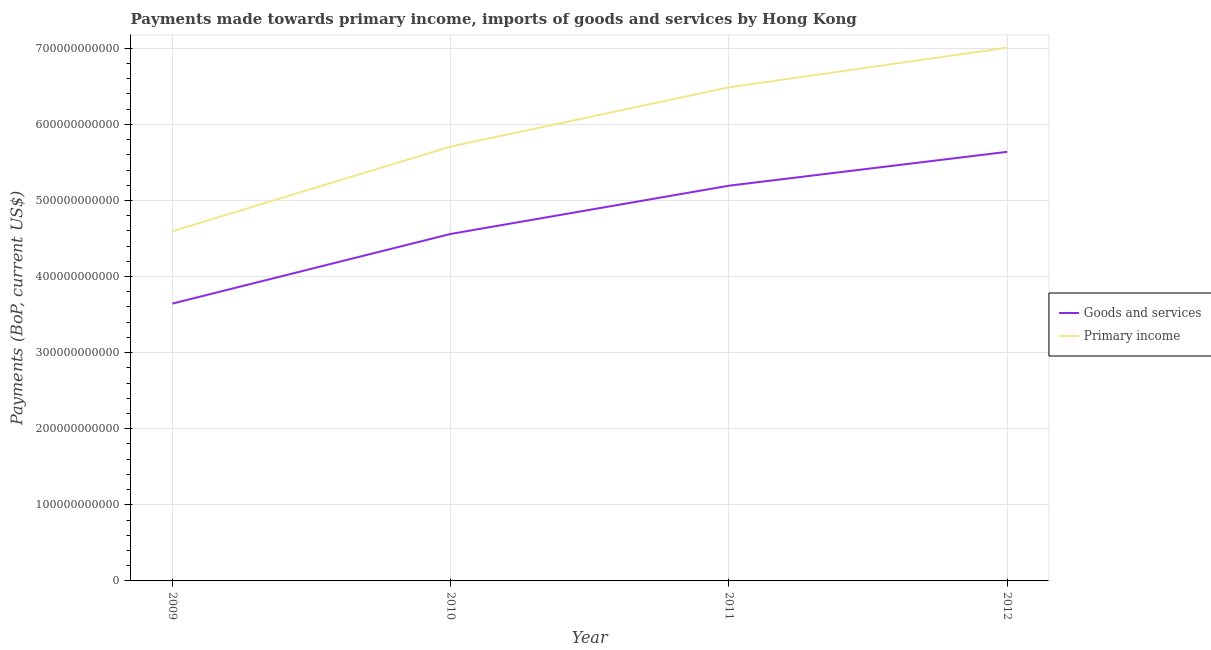Does the line corresponding to payments made towards goods and services intersect with the line corresponding to payments made towards primary income?
Offer a terse response. No. Is the number of lines equal to the number of legend labels?
Keep it short and to the point. Yes. What is the payments made towards goods and services in 2009?
Keep it short and to the point. 3.64e+11. Across all years, what is the maximum payments made towards goods and services?
Offer a terse response. 5.64e+11. Across all years, what is the minimum payments made towards primary income?
Provide a succinct answer. 4.60e+11. In which year was the payments made towards goods and services minimum?
Offer a very short reply. 2009. What is the total payments made towards primary income in the graph?
Ensure brevity in your answer.  2.38e+12. What is the difference between the payments made towards primary income in 2010 and that in 2011?
Your answer should be very brief. -7.79e+1. What is the difference between the payments made towards primary income in 2011 and the payments made towards goods and services in 2009?
Ensure brevity in your answer.  2.84e+11. What is the average payments made towards goods and services per year?
Make the answer very short. 4.76e+11. In the year 2010, what is the difference between the payments made towards goods and services and payments made towards primary income?
Provide a succinct answer. -1.15e+11. What is the ratio of the payments made towards goods and services in 2010 to that in 2011?
Your answer should be very brief. 0.88. Is the payments made towards primary income in 2009 less than that in 2011?
Offer a terse response. Yes. What is the difference between the highest and the second highest payments made towards primary income?
Your answer should be very brief. 5.21e+1. What is the difference between the highest and the lowest payments made towards primary income?
Ensure brevity in your answer.  2.41e+11. In how many years, is the payments made towards goods and services greater than the average payments made towards goods and services taken over all years?
Ensure brevity in your answer.  2. Is the sum of the payments made towards primary income in 2010 and 2011 greater than the maximum payments made towards goods and services across all years?
Give a very brief answer. Yes. Does the payments made towards goods and services monotonically increase over the years?
Provide a short and direct response. Yes. Is the payments made towards goods and services strictly less than the payments made towards primary income over the years?
Keep it short and to the point. Yes. What is the difference between two consecutive major ticks on the Y-axis?
Keep it short and to the point. 1.00e+11. What is the title of the graph?
Keep it short and to the point. Payments made towards primary income, imports of goods and services by Hong Kong. What is the label or title of the X-axis?
Provide a succinct answer. Year. What is the label or title of the Y-axis?
Ensure brevity in your answer.  Payments (BoP, current US$). What is the Payments (BoP, current US$) of Goods and services in 2009?
Your answer should be compact. 3.64e+11. What is the Payments (BoP, current US$) in Primary income in 2009?
Give a very brief answer. 4.60e+11. What is the Payments (BoP, current US$) of Goods and services in 2010?
Ensure brevity in your answer.  4.56e+11. What is the Payments (BoP, current US$) of Primary income in 2010?
Offer a terse response. 5.71e+11. What is the Payments (BoP, current US$) of Goods and services in 2011?
Make the answer very short. 5.19e+11. What is the Payments (BoP, current US$) of Primary income in 2011?
Offer a terse response. 6.49e+11. What is the Payments (BoP, current US$) of Goods and services in 2012?
Make the answer very short. 5.64e+11. What is the Payments (BoP, current US$) in Primary income in 2012?
Ensure brevity in your answer.  7.01e+11. Across all years, what is the maximum Payments (BoP, current US$) of Goods and services?
Your answer should be very brief. 5.64e+11. Across all years, what is the maximum Payments (BoP, current US$) of Primary income?
Make the answer very short. 7.01e+11. Across all years, what is the minimum Payments (BoP, current US$) of Goods and services?
Keep it short and to the point. 3.64e+11. Across all years, what is the minimum Payments (BoP, current US$) in Primary income?
Your response must be concise. 4.60e+11. What is the total Payments (BoP, current US$) in Goods and services in the graph?
Give a very brief answer. 1.90e+12. What is the total Payments (BoP, current US$) in Primary income in the graph?
Your answer should be compact. 2.38e+12. What is the difference between the Payments (BoP, current US$) in Goods and services in 2009 and that in 2010?
Ensure brevity in your answer.  -9.16e+1. What is the difference between the Payments (BoP, current US$) of Primary income in 2009 and that in 2010?
Ensure brevity in your answer.  -1.11e+11. What is the difference between the Payments (BoP, current US$) of Goods and services in 2009 and that in 2011?
Ensure brevity in your answer.  -1.55e+11. What is the difference between the Payments (BoP, current US$) in Primary income in 2009 and that in 2011?
Make the answer very short. -1.89e+11. What is the difference between the Payments (BoP, current US$) of Goods and services in 2009 and that in 2012?
Your answer should be compact. -1.99e+11. What is the difference between the Payments (BoP, current US$) of Primary income in 2009 and that in 2012?
Provide a succinct answer. -2.41e+11. What is the difference between the Payments (BoP, current US$) of Goods and services in 2010 and that in 2011?
Offer a very short reply. -6.34e+1. What is the difference between the Payments (BoP, current US$) in Primary income in 2010 and that in 2011?
Ensure brevity in your answer.  -7.79e+1. What is the difference between the Payments (BoP, current US$) in Goods and services in 2010 and that in 2012?
Your response must be concise. -1.08e+11. What is the difference between the Payments (BoP, current US$) in Primary income in 2010 and that in 2012?
Your response must be concise. -1.30e+11. What is the difference between the Payments (BoP, current US$) of Goods and services in 2011 and that in 2012?
Your answer should be compact. -4.45e+1. What is the difference between the Payments (BoP, current US$) in Primary income in 2011 and that in 2012?
Your answer should be compact. -5.21e+1. What is the difference between the Payments (BoP, current US$) in Goods and services in 2009 and the Payments (BoP, current US$) in Primary income in 2010?
Keep it short and to the point. -2.06e+11. What is the difference between the Payments (BoP, current US$) in Goods and services in 2009 and the Payments (BoP, current US$) in Primary income in 2011?
Provide a short and direct response. -2.84e+11. What is the difference between the Payments (BoP, current US$) in Goods and services in 2009 and the Payments (BoP, current US$) in Primary income in 2012?
Your answer should be compact. -3.36e+11. What is the difference between the Payments (BoP, current US$) of Goods and services in 2010 and the Payments (BoP, current US$) of Primary income in 2011?
Your answer should be compact. -1.93e+11. What is the difference between the Payments (BoP, current US$) in Goods and services in 2010 and the Payments (BoP, current US$) in Primary income in 2012?
Your answer should be very brief. -2.45e+11. What is the difference between the Payments (BoP, current US$) of Goods and services in 2011 and the Payments (BoP, current US$) of Primary income in 2012?
Make the answer very short. -1.81e+11. What is the average Payments (BoP, current US$) in Goods and services per year?
Keep it short and to the point. 4.76e+11. What is the average Payments (BoP, current US$) of Primary income per year?
Offer a very short reply. 5.95e+11. In the year 2009, what is the difference between the Payments (BoP, current US$) in Goods and services and Payments (BoP, current US$) in Primary income?
Offer a terse response. -9.51e+1. In the year 2010, what is the difference between the Payments (BoP, current US$) in Goods and services and Payments (BoP, current US$) in Primary income?
Your answer should be very brief. -1.15e+11. In the year 2011, what is the difference between the Payments (BoP, current US$) of Goods and services and Payments (BoP, current US$) of Primary income?
Make the answer very short. -1.29e+11. In the year 2012, what is the difference between the Payments (BoP, current US$) of Goods and services and Payments (BoP, current US$) of Primary income?
Make the answer very short. -1.37e+11. What is the ratio of the Payments (BoP, current US$) in Goods and services in 2009 to that in 2010?
Provide a succinct answer. 0.8. What is the ratio of the Payments (BoP, current US$) in Primary income in 2009 to that in 2010?
Your answer should be compact. 0.81. What is the ratio of the Payments (BoP, current US$) of Goods and services in 2009 to that in 2011?
Offer a terse response. 0.7. What is the ratio of the Payments (BoP, current US$) in Primary income in 2009 to that in 2011?
Provide a short and direct response. 0.71. What is the ratio of the Payments (BoP, current US$) of Goods and services in 2009 to that in 2012?
Your answer should be very brief. 0.65. What is the ratio of the Payments (BoP, current US$) of Primary income in 2009 to that in 2012?
Ensure brevity in your answer.  0.66. What is the ratio of the Payments (BoP, current US$) in Goods and services in 2010 to that in 2011?
Keep it short and to the point. 0.88. What is the ratio of the Payments (BoP, current US$) in Primary income in 2010 to that in 2011?
Make the answer very short. 0.88. What is the ratio of the Payments (BoP, current US$) of Goods and services in 2010 to that in 2012?
Offer a terse response. 0.81. What is the ratio of the Payments (BoP, current US$) in Primary income in 2010 to that in 2012?
Provide a succinct answer. 0.81. What is the ratio of the Payments (BoP, current US$) in Goods and services in 2011 to that in 2012?
Your answer should be very brief. 0.92. What is the ratio of the Payments (BoP, current US$) in Primary income in 2011 to that in 2012?
Your answer should be very brief. 0.93. What is the difference between the highest and the second highest Payments (BoP, current US$) in Goods and services?
Give a very brief answer. 4.45e+1. What is the difference between the highest and the second highest Payments (BoP, current US$) in Primary income?
Make the answer very short. 5.21e+1. What is the difference between the highest and the lowest Payments (BoP, current US$) in Goods and services?
Ensure brevity in your answer.  1.99e+11. What is the difference between the highest and the lowest Payments (BoP, current US$) of Primary income?
Give a very brief answer. 2.41e+11. 